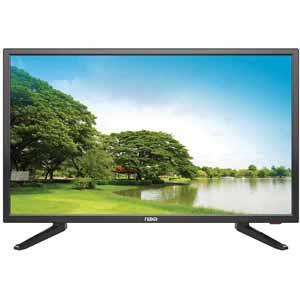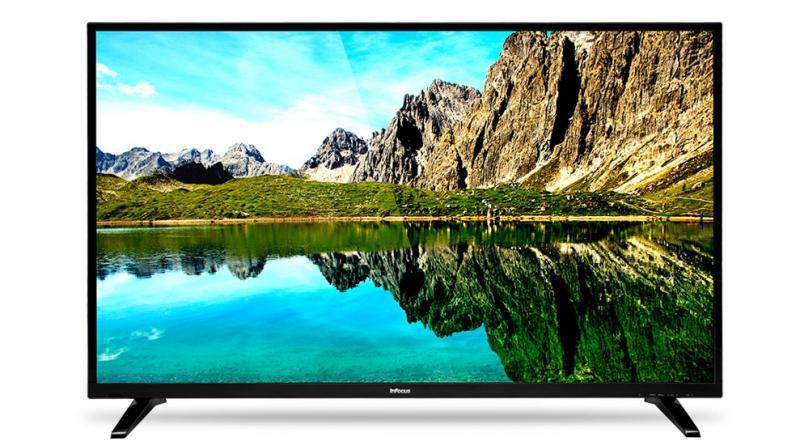The first image is the image on the left, the second image is the image on the right. Analyze the images presented: Is the assertion "Both monitors have one leg." valid? Answer yes or no. No. The first image is the image on the left, the second image is the image on the right. For the images displayed, is the sentence "Each television has a similar size and alignment" factually correct? Answer yes or no. No. 